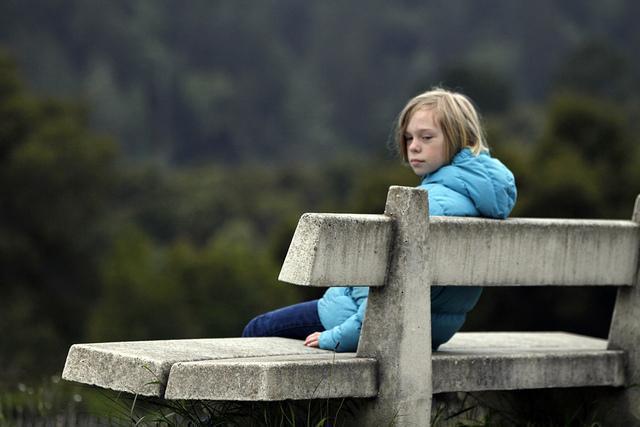How many people are in the picture?
Give a very brief answer. 1. How many people are visible?
Give a very brief answer. 1. How many miniature horses are there in the field?
Give a very brief answer. 0. 